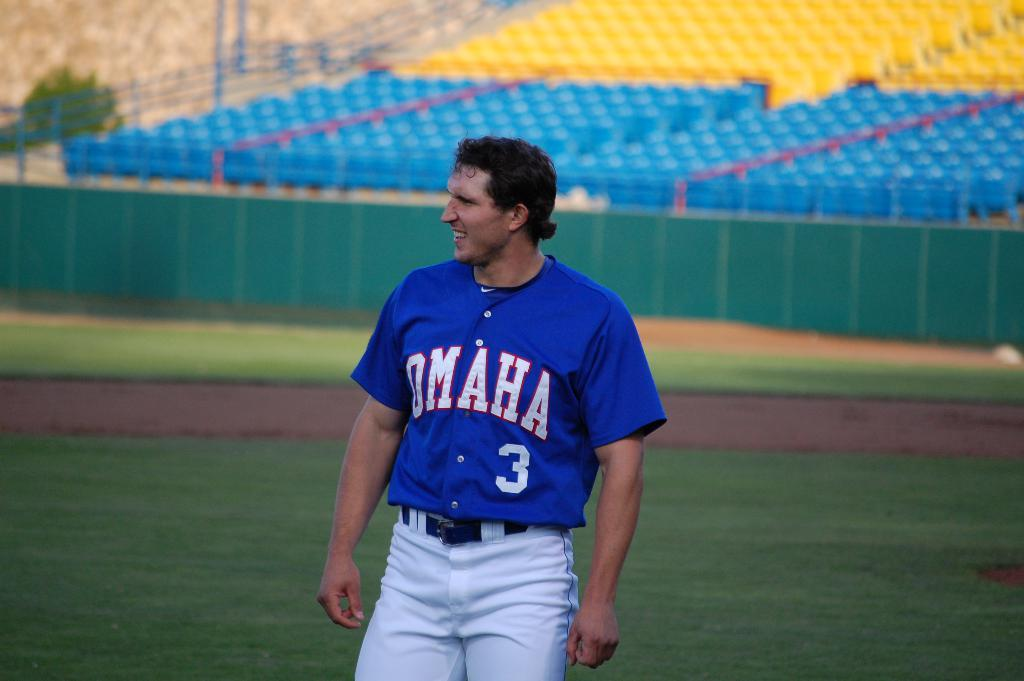<image>
Provide a brief description of the given image. a baseball player wearing a blue jersey from omaha number 3 